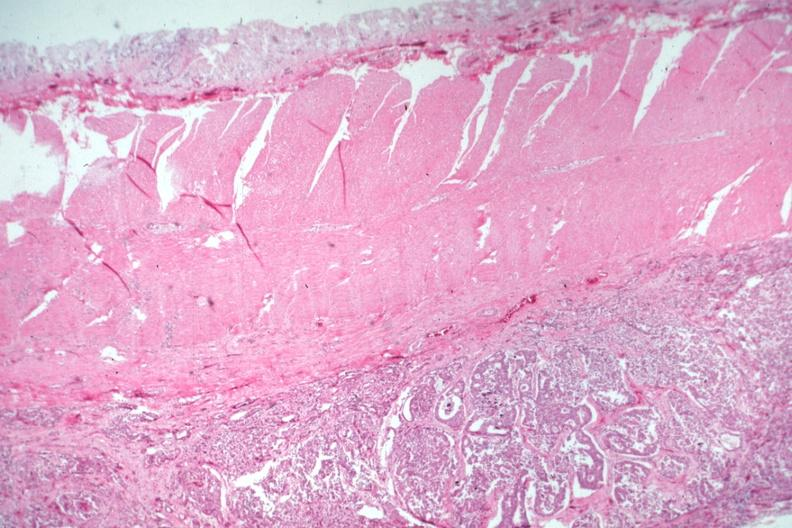s gastrointestinal present?
Answer the question using a single word or phrase. Yes 